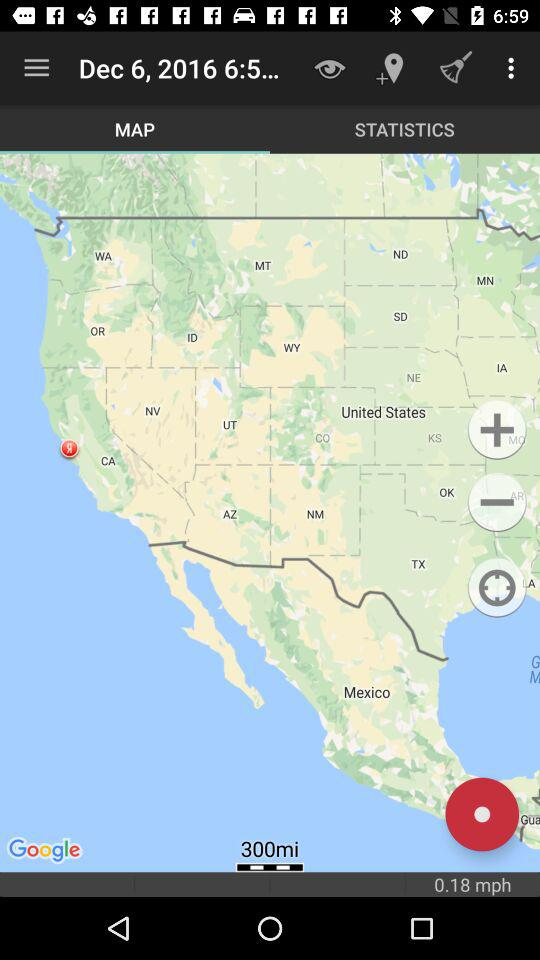What is the average speed of the user?
Answer the question using a single word or phrase. 0.18 mph 